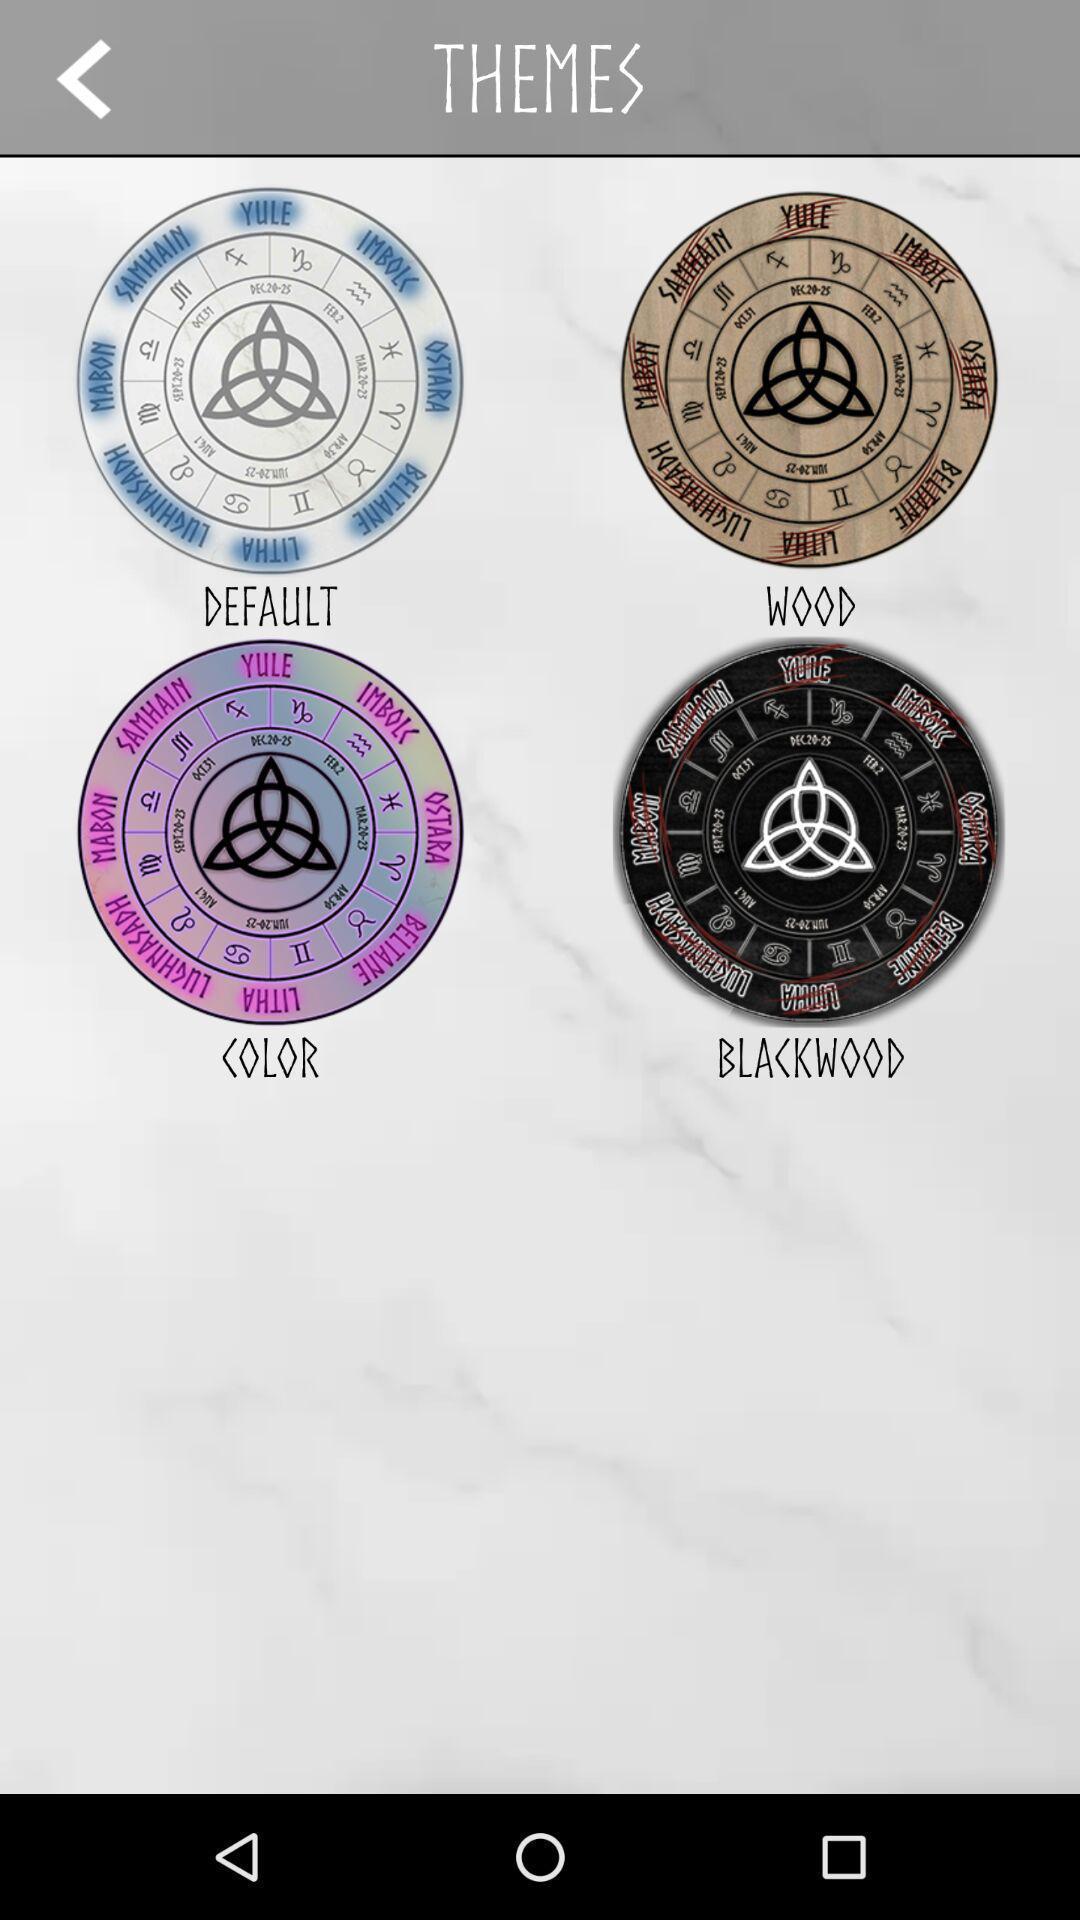What details can you identify in this image? Screen displaying different kinds of themes. 